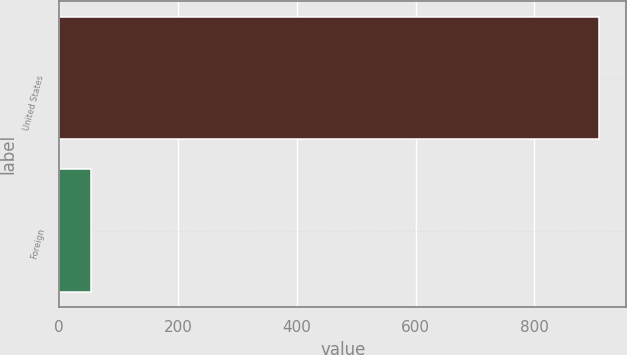<chart> <loc_0><loc_0><loc_500><loc_500><bar_chart><fcel>United States<fcel>Foreign<nl><fcel>909.2<fcel>53.2<nl></chart> 